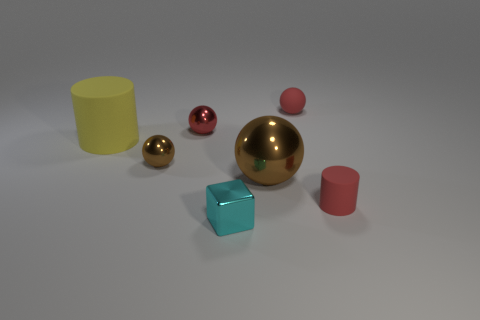Are there any big green cubes that have the same material as the small cylinder?
Keep it short and to the point. No. Do the metal block that is in front of the red cylinder and the large ball have the same size?
Offer a very short reply. No. How many blue things are either rubber objects or tiny shiny balls?
Keep it short and to the point. 0. There is a tiny cyan cube that is right of the large yellow matte object; what is it made of?
Your answer should be very brief. Metal. There is a small sphere in front of the large matte cylinder; how many red matte things are behind it?
Your answer should be compact. 1. How many matte objects are the same shape as the red metal object?
Make the answer very short. 1. How many brown spheres are there?
Provide a short and direct response. 2. What is the color of the tiny object that is in front of the small red rubber cylinder?
Ensure brevity in your answer.  Cyan. What is the color of the cylinder behind the rubber thing in front of the yellow matte thing?
Provide a succinct answer. Yellow. The cylinder that is the same size as the red shiny sphere is what color?
Ensure brevity in your answer.  Red. 